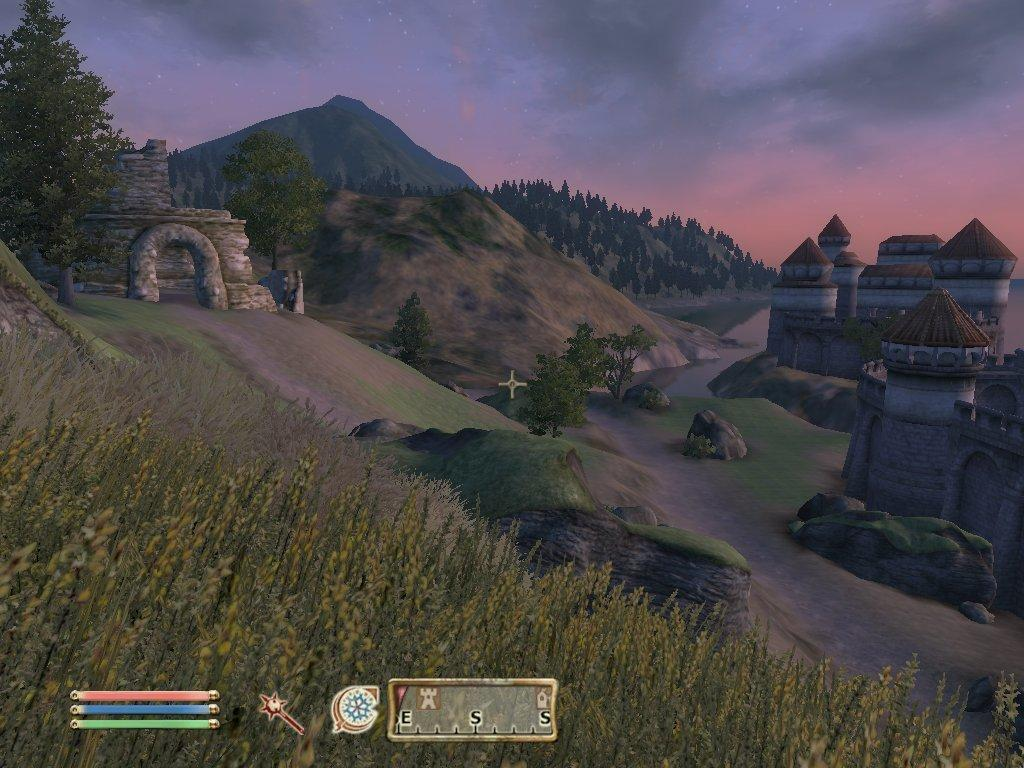What type of objects are animated in the image? The image contains animated trees, buildings, and sky. Are there any other animated elements in the image besides trees, buildings, and sky? Yes, there are other animated elements in the image. Can you describe the animated sky in the image? The image contains an animated sky. What type of butter can be seen melting on the rhythm in the image? There is no butter or rhythm present in the image; it contains animated trees, buildings, and sky, along with other animated elements. 